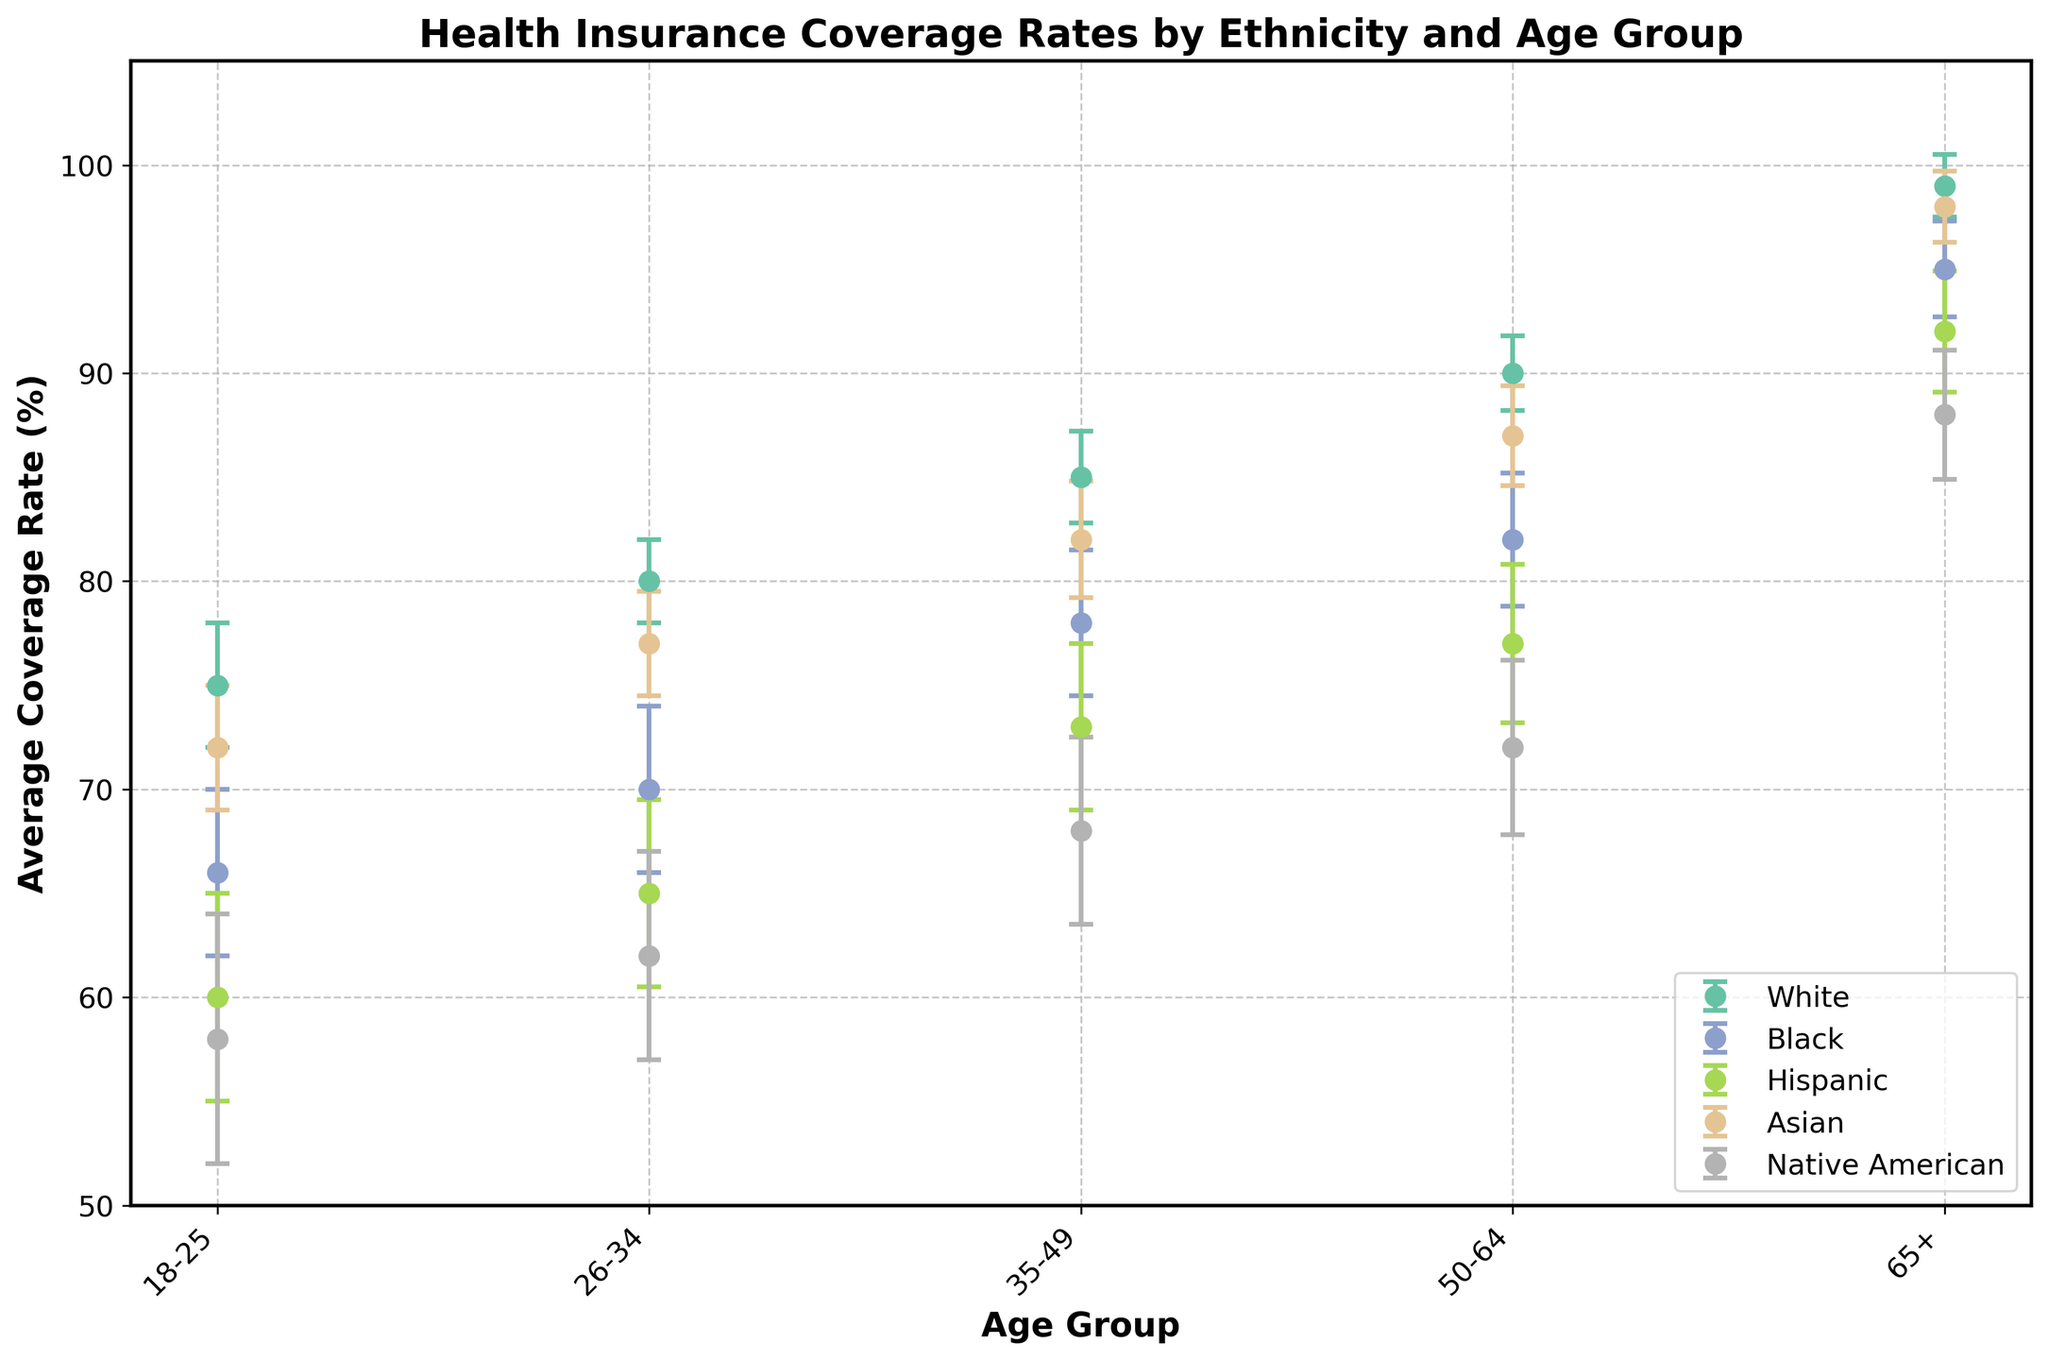Which age group has the highest health insurance coverage rate for White individuals? Look for the age group with the highest dot representing White individuals. Here, the highest health insurance coverage rate for White individuals is shown at the 65+ age group.
Answer: 65+ What is the difference in average coverage rate between Asian and Hispanic individuals aged 50-64? Find the average coverage rates for Asian and Hispanic individuals aged 50-64, then subtract the Hispanic rate from the Asian rate. The rates are 87% for Asian and 77% for Hispanic. So, 87% - 77% = 10%.
Answer: 10% Which ethnicity has the most significant variability in health insurance coverage rates for the 18-25 age group? Look at the lengths of the error bars for each ethnicity in the 18-25 age group. The ethnicity with the longest error bars has the highest variability. For the 18-25 age group, Native American has the most significant variability with a standard deviation of 6%.
Answer: Native American Are health insurance coverage rates generally increasing or decreasing with age for Black individuals? Observe the trend of the dots for Black individuals across age groups from 18-25 to 65+. The dots are positioned higher as the age group increases, indicating increasing coverage rates.
Answer: Increasing What is the approximate average insurance coverage rate for all ethnicities combined in the 35-49 age group? Calculate the average of the coverage rates for all ethnicities in the 35-49 age group. The values are 85, 78, 73, 82, and 68. The sum is 386, and there are 5 data points, so 386 / 5 = 77.2%.
Answer: 77.2% Which ethnicity has the lowest average coverage rate in the 26-34 age group? Identify the dot with the lowest position in the 26-34 age group. Native American has the lowest average coverage rate in this age group, which is 62%.
Answer: Native American How does the average coverage rate for Asians in the 18-25 age group compare to the average coverage rate for Hispanics in the 26-34 age group? Compare the two average coverage rates directly. Asians in the 18-25 age group have a 72% coverage rate and Hispanics in the 26-34 age group have a 65% coverage rate. Asians have a higher coverage rate by 7%.
Answer: Asians have 7% higher What is the range of coverage rates for Native Americans across all age groups? Identify the highest and lowest average coverage rates for Native Americans across all age groups. The highest rate is 88% (65+ age group) and the lowest is 58% (18-25 age group). The range is 88% - 58% = 30%.
Answer: 30% Which age group shows the smallest variability in coverage rates for all ethnicities combined? Inspect the error bars across age groups and ethnicities and find the group with consistently shorter error bars. The 65+ age group shows the smallest variability, indicated by the shorter error bars across all ethnicities.
Answer: 65+ 